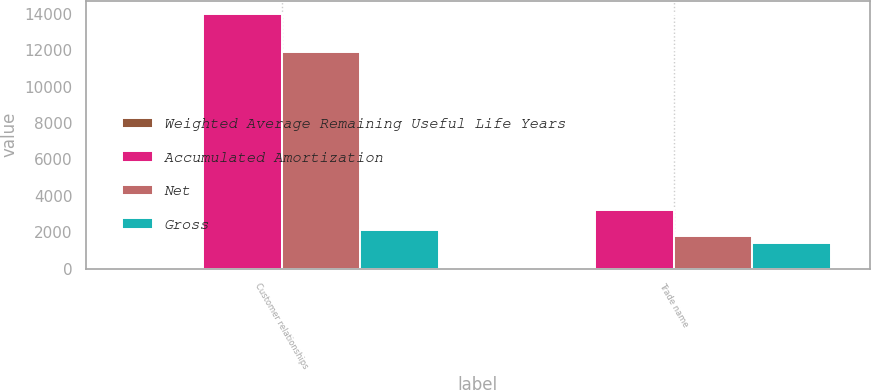Convert chart. <chart><loc_0><loc_0><loc_500><loc_500><stacked_bar_chart><ecel><fcel>Customer relationships<fcel>Trade name<nl><fcel>Weighted Average Remaining Useful Life Years<fcel>1.5<fcel>6.5<nl><fcel>Accumulated Amortization<fcel>13997<fcel>3194<nl><fcel>Net<fcel>11897<fcel>1810<nl><fcel>Gross<fcel>2100<fcel>1384<nl></chart> 